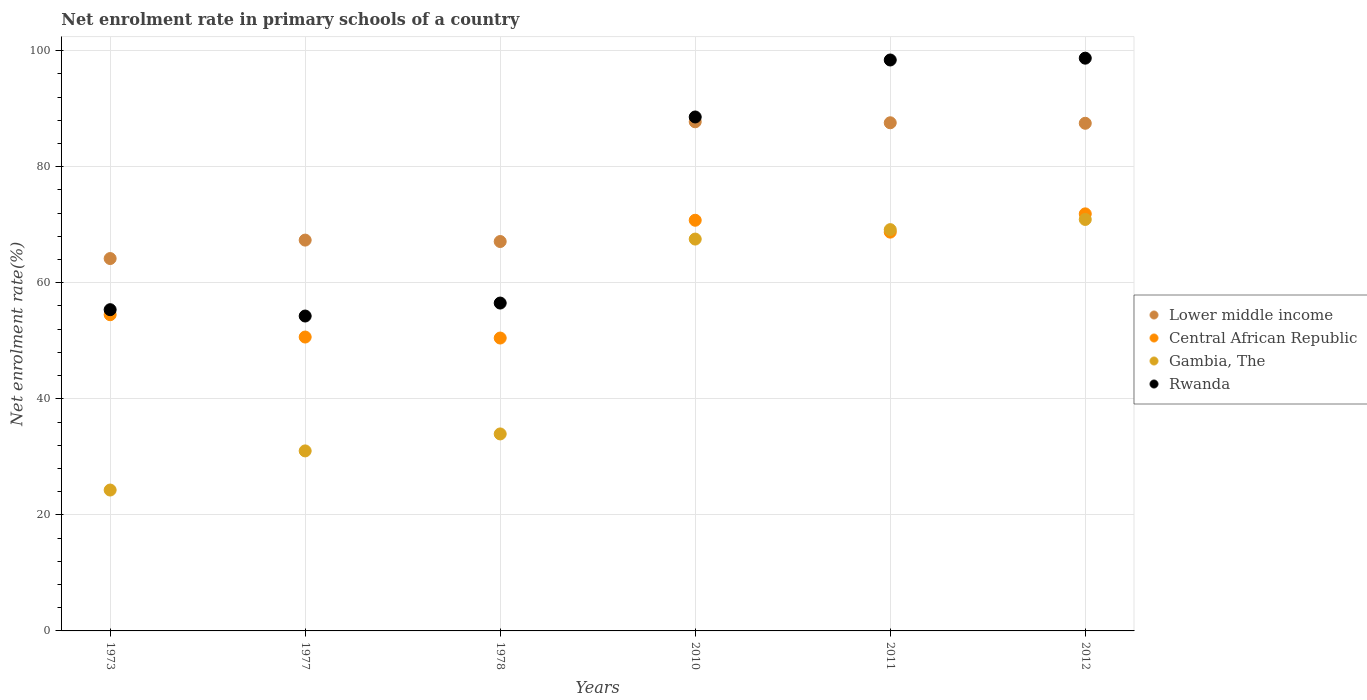Is the number of dotlines equal to the number of legend labels?
Your response must be concise. Yes. What is the net enrolment rate in primary schools in Lower middle income in 1977?
Provide a short and direct response. 67.35. Across all years, what is the maximum net enrolment rate in primary schools in Central African Republic?
Your answer should be very brief. 71.88. Across all years, what is the minimum net enrolment rate in primary schools in Central African Republic?
Give a very brief answer. 50.48. In which year was the net enrolment rate in primary schools in Gambia, The maximum?
Your response must be concise. 2012. What is the total net enrolment rate in primary schools in Rwanda in the graph?
Provide a short and direct response. 451.81. What is the difference between the net enrolment rate in primary schools in Gambia, The in 1978 and that in 2012?
Ensure brevity in your answer.  -36.96. What is the difference between the net enrolment rate in primary schools in Lower middle income in 1973 and the net enrolment rate in primary schools in Gambia, The in 2010?
Your answer should be very brief. -3.36. What is the average net enrolment rate in primary schools in Central African Republic per year?
Your answer should be compact. 61.17. In the year 2012, what is the difference between the net enrolment rate in primary schools in Rwanda and net enrolment rate in primary schools in Gambia, The?
Make the answer very short. 27.8. What is the ratio of the net enrolment rate in primary schools in Gambia, The in 2011 to that in 2012?
Give a very brief answer. 0.98. What is the difference between the highest and the second highest net enrolment rate in primary schools in Central African Republic?
Your answer should be very brief. 1.1. What is the difference between the highest and the lowest net enrolment rate in primary schools in Lower middle income?
Make the answer very short. 23.57. In how many years, is the net enrolment rate in primary schools in Rwanda greater than the average net enrolment rate in primary schools in Rwanda taken over all years?
Your response must be concise. 3. Is it the case that in every year, the sum of the net enrolment rate in primary schools in Rwanda and net enrolment rate in primary schools in Lower middle income  is greater than the sum of net enrolment rate in primary schools in Central African Republic and net enrolment rate in primary schools in Gambia, The?
Make the answer very short. Yes. Is it the case that in every year, the sum of the net enrolment rate in primary schools in Rwanda and net enrolment rate in primary schools in Central African Republic  is greater than the net enrolment rate in primary schools in Lower middle income?
Your answer should be compact. Yes. Does the net enrolment rate in primary schools in Lower middle income monotonically increase over the years?
Keep it short and to the point. No. Is the net enrolment rate in primary schools in Lower middle income strictly greater than the net enrolment rate in primary schools in Rwanda over the years?
Your answer should be compact. No. How many dotlines are there?
Your answer should be very brief. 4. How many years are there in the graph?
Your response must be concise. 6. Does the graph contain grids?
Offer a terse response. Yes. How many legend labels are there?
Offer a terse response. 4. How are the legend labels stacked?
Your response must be concise. Vertical. What is the title of the graph?
Provide a short and direct response. Net enrolment rate in primary schools of a country. Does "Norway" appear as one of the legend labels in the graph?
Give a very brief answer. No. What is the label or title of the X-axis?
Your response must be concise. Years. What is the label or title of the Y-axis?
Provide a succinct answer. Net enrolment rate(%). What is the Net enrolment rate(%) of Lower middle income in 1973?
Provide a succinct answer. 64.18. What is the Net enrolment rate(%) in Central African Republic in 1973?
Make the answer very short. 54.5. What is the Net enrolment rate(%) in Gambia, The in 1973?
Ensure brevity in your answer.  24.28. What is the Net enrolment rate(%) of Rwanda in 1973?
Give a very brief answer. 55.36. What is the Net enrolment rate(%) in Lower middle income in 1977?
Keep it short and to the point. 67.35. What is the Net enrolment rate(%) of Central African Republic in 1977?
Provide a short and direct response. 50.65. What is the Net enrolment rate(%) of Gambia, The in 1977?
Give a very brief answer. 31.02. What is the Net enrolment rate(%) in Rwanda in 1977?
Your answer should be very brief. 54.27. What is the Net enrolment rate(%) of Lower middle income in 1978?
Offer a terse response. 67.11. What is the Net enrolment rate(%) of Central African Republic in 1978?
Ensure brevity in your answer.  50.48. What is the Net enrolment rate(%) in Gambia, The in 1978?
Your response must be concise. 33.95. What is the Net enrolment rate(%) of Rwanda in 1978?
Your answer should be very brief. 56.5. What is the Net enrolment rate(%) in Lower middle income in 2010?
Ensure brevity in your answer.  87.74. What is the Net enrolment rate(%) in Central African Republic in 2010?
Keep it short and to the point. 70.77. What is the Net enrolment rate(%) of Gambia, The in 2010?
Provide a short and direct response. 67.53. What is the Net enrolment rate(%) in Rwanda in 2010?
Keep it short and to the point. 88.57. What is the Net enrolment rate(%) of Lower middle income in 2011?
Your answer should be very brief. 87.57. What is the Net enrolment rate(%) of Central African Republic in 2011?
Provide a short and direct response. 68.73. What is the Net enrolment rate(%) of Gambia, The in 2011?
Your answer should be very brief. 69.16. What is the Net enrolment rate(%) in Rwanda in 2011?
Provide a short and direct response. 98.39. What is the Net enrolment rate(%) of Lower middle income in 2012?
Give a very brief answer. 87.49. What is the Net enrolment rate(%) in Central African Republic in 2012?
Your answer should be compact. 71.88. What is the Net enrolment rate(%) of Gambia, The in 2012?
Give a very brief answer. 70.91. What is the Net enrolment rate(%) in Rwanda in 2012?
Provide a succinct answer. 98.71. Across all years, what is the maximum Net enrolment rate(%) of Lower middle income?
Offer a terse response. 87.74. Across all years, what is the maximum Net enrolment rate(%) of Central African Republic?
Your answer should be very brief. 71.88. Across all years, what is the maximum Net enrolment rate(%) of Gambia, The?
Your answer should be compact. 70.91. Across all years, what is the maximum Net enrolment rate(%) of Rwanda?
Offer a terse response. 98.71. Across all years, what is the minimum Net enrolment rate(%) in Lower middle income?
Your answer should be compact. 64.18. Across all years, what is the minimum Net enrolment rate(%) of Central African Republic?
Make the answer very short. 50.48. Across all years, what is the minimum Net enrolment rate(%) in Gambia, The?
Your response must be concise. 24.28. Across all years, what is the minimum Net enrolment rate(%) of Rwanda?
Ensure brevity in your answer.  54.27. What is the total Net enrolment rate(%) in Lower middle income in the graph?
Offer a terse response. 461.44. What is the total Net enrolment rate(%) of Central African Republic in the graph?
Ensure brevity in your answer.  367. What is the total Net enrolment rate(%) of Gambia, The in the graph?
Offer a very short reply. 296.86. What is the total Net enrolment rate(%) of Rwanda in the graph?
Your answer should be very brief. 451.81. What is the difference between the Net enrolment rate(%) in Lower middle income in 1973 and that in 1977?
Your answer should be very brief. -3.18. What is the difference between the Net enrolment rate(%) of Central African Republic in 1973 and that in 1977?
Give a very brief answer. 3.85. What is the difference between the Net enrolment rate(%) in Gambia, The in 1973 and that in 1977?
Your answer should be very brief. -6.74. What is the difference between the Net enrolment rate(%) of Rwanda in 1973 and that in 1977?
Your answer should be very brief. 1.09. What is the difference between the Net enrolment rate(%) in Lower middle income in 1973 and that in 1978?
Your answer should be compact. -2.93. What is the difference between the Net enrolment rate(%) of Central African Republic in 1973 and that in 1978?
Provide a succinct answer. 4.02. What is the difference between the Net enrolment rate(%) in Gambia, The in 1973 and that in 1978?
Your response must be concise. -9.67. What is the difference between the Net enrolment rate(%) in Rwanda in 1973 and that in 1978?
Provide a succinct answer. -1.14. What is the difference between the Net enrolment rate(%) in Lower middle income in 1973 and that in 2010?
Offer a very short reply. -23.57. What is the difference between the Net enrolment rate(%) of Central African Republic in 1973 and that in 2010?
Offer a very short reply. -16.28. What is the difference between the Net enrolment rate(%) of Gambia, The in 1973 and that in 2010?
Your response must be concise. -43.25. What is the difference between the Net enrolment rate(%) in Rwanda in 1973 and that in 2010?
Give a very brief answer. -33.21. What is the difference between the Net enrolment rate(%) of Lower middle income in 1973 and that in 2011?
Provide a short and direct response. -23.4. What is the difference between the Net enrolment rate(%) in Central African Republic in 1973 and that in 2011?
Give a very brief answer. -14.23. What is the difference between the Net enrolment rate(%) of Gambia, The in 1973 and that in 2011?
Your answer should be compact. -44.88. What is the difference between the Net enrolment rate(%) of Rwanda in 1973 and that in 2011?
Give a very brief answer. -43.03. What is the difference between the Net enrolment rate(%) in Lower middle income in 1973 and that in 2012?
Ensure brevity in your answer.  -23.31. What is the difference between the Net enrolment rate(%) in Central African Republic in 1973 and that in 2012?
Your response must be concise. -17.38. What is the difference between the Net enrolment rate(%) in Gambia, The in 1973 and that in 2012?
Offer a very short reply. -46.63. What is the difference between the Net enrolment rate(%) in Rwanda in 1973 and that in 2012?
Provide a short and direct response. -43.35. What is the difference between the Net enrolment rate(%) in Lower middle income in 1977 and that in 1978?
Ensure brevity in your answer.  0.24. What is the difference between the Net enrolment rate(%) in Central African Republic in 1977 and that in 1978?
Your response must be concise. 0.17. What is the difference between the Net enrolment rate(%) of Gambia, The in 1977 and that in 1978?
Provide a short and direct response. -2.92. What is the difference between the Net enrolment rate(%) in Rwanda in 1977 and that in 1978?
Offer a very short reply. -2.24. What is the difference between the Net enrolment rate(%) of Lower middle income in 1977 and that in 2010?
Keep it short and to the point. -20.39. What is the difference between the Net enrolment rate(%) of Central African Republic in 1977 and that in 2010?
Offer a terse response. -20.13. What is the difference between the Net enrolment rate(%) of Gambia, The in 1977 and that in 2010?
Keep it short and to the point. -36.51. What is the difference between the Net enrolment rate(%) of Rwanda in 1977 and that in 2010?
Make the answer very short. -34.3. What is the difference between the Net enrolment rate(%) of Lower middle income in 1977 and that in 2011?
Provide a succinct answer. -20.22. What is the difference between the Net enrolment rate(%) of Central African Republic in 1977 and that in 2011?
Give a very brief answer. -18.08. What is the difference between the Net enrolment rate(%) in Gambia, The in 1977 and that in 2011?
Offer a very short reply. -38.13. What is the difference between the Net enrolment rate(%) of Rwanda in 1977 and that in 2011?
Your response must be concise. -44.13. What is the difference between the Net enrolment rate(%) in Lower middle income in 1977 and that in 2012?
Make the answer very short. -20.13. What is the difference between the Net enrolment rate(%) in Central African Republic in 1977 and that in 2012?
Ensure brevity in your answer.  -21.23. What is the difference between the Net enrolment rate(%) of Gambia, The in 1977 and that in 2012?
Provide a succinct answer. -39.89. What is the difference between the Net enrolment rate(%) of Rwanda in 1977 and that in 2012?
Your response must be concise. -44.44. What is the difference between the Net enrolment rate(%) of Lower middle income in 1978 and that in 2010?
Keep it short and to the point. -20.63. What is the difference between the Net enrolment rate(%) in Central African Republic in 1978 and that in 2010?
Make the answer very short. -20.3. What is the difference between the Net enrolment rate(%) of Gambia, The in 1978 and that in 2010?
Make the answer very short. -33.58. What is the difference between the Net enrolment rate(%) of Rwanda in 1978 and that in 2010?
Offer a very short reply. -32.07. What is the difference between the Net enrolment rate(%) in Lower middle income in 1978 and that in 2011?
Ensure brevity in your answer.  -20.46. What is the difference between the Net enrolment rate(%) of Central African Republic in 1978 and that in 2011?
Provide a succinct answer. -18.25. What is the difference between the Net enrolment rate(%) in Gambia, The in 1978 and that in 2011?
Give a very brief answer. -35.21. What is the difference between the Net enrolment rate(%) in Rwanda in 1978 and that in 2011?
Your answer should be compact. -41.89. What is the difference between the Net enrolment rate(%) of Lower middle income in 1978 and that in 2012?
Offer a terse response. -20.38. What is the difference between the Net enrolment rate(%) of Central African Republic in 1978 and that in 2012?
Make the answer very short. -21.4. What is the difference between the Net enrolment rate(%) of Gambia, The in 1978 and that in 2012?
Keep it short and to the point. -36.96. What is the difference between the Net enrolment rate(%) in Rwanda in 1978 and that in 2012?
Ensure brevity in your answer.  -42.2. What is the difference between the Net enrolment rate(%) in Lower middle income in 2010 and that in 2011?
Give a very brief answer. 0.17. What is the difference between the Net enrolment rate(%) in Central African Republic in 2010 and that in 2011?
Your answer should be very brief. 2.05. What is the difference between the Net enrolment rate(%) in Gambia, The in 2010 and that in 2011?
Offer a very short reply. -1.63. What is the difference between the Net enrolment rate(%) of Rwanda in 2010 and that in 2011?
Offer a terse response. -9.82. What is the difference between the Net enrolment rate(%) in Lower middle income in 2010 and that in 2012?
Offer a very short reply. 0.25. What is the difference between the Net enrolment rate(%) of Central African Republic in 2010 and that in 2012?
Give a very brief answer. -1.1. What is the difference between the Net enrolment rate(%) in Gambia, The in 2010 and that in 2012?
Give a very brief answer. -3.38. What is the difference between the Net enrolment rate(%) in Rwanda in 2010 and that in 2012?
Your response must be concise. -10.14. What is the difference between the Net enrolment rate(%) of Lower middle income in 2011 and that in 2012?
Your response must be concise. 0.09. What is the difference between the Net enrolment rate(%) of Central African Republic in 2011 and that in 2012?
Offer a terse response. -3.15. What is the difference between the Net enrolment rate(%) in Gambia, The in 2011 and that in 2012?
Provide a succinct answer. -1.75. What is the difference between the Net enrolment rate(%) in Rwanda in 2011 and that in 2012?
Ensure brevity in your answer.  -0.31. What is the difference between the Net enrolment rate(%) of Lower middle income in 1973 and the Net enrolment rate(%) of Central African Republic in 1977?
Make the answer very short. 13.53. What is the difference between the Net enrolment rate(%) in Lower middle income in 1973 and the Net enrolment rate(%) in Gambia, The in 1977?
Provide a succinct answer. 33.15. What is the difference between the Net enrolment rate(%) of Lower middle income in 1973 and the Net enrolment rate(%) of Rwanda in 1977?
Your response must be concise. 9.91. What is the difference between the Net enrolment rate(%) of Central African Republic in 1973 and the Net enrolment rate(%) of Gambia, The in 1977?
Provide a succinct answer. 23.47. What is the difference between the Net enrolment rate(%) in Central African Republic in 1973 and the Net enrolment rate(%) in Rwanda in 1977?
Provide a succinct answer. 0.23. What is the difference between the Net enrolment rate(%) in Gambia, The in 1973 and the Net enrolment rate(%) in Rwanda in 1977?
Your answer should be compact. -29.99. What is the difference between the Net enrolment rate(%) of Lower middle income in 1973 and the Net enrolment rate(%) of Central African Republic in 1978?
Ensure brevity in your answer.  13.7. What is the difference between the Net enrolment rate(%) of Lower middle income in 1973 and the Net enrolment rate(%) of Gambia, The in 1978?
Offer a terse response. 30.23. What is the difference between the Net enrolment rate(%) of Lower middle income in 1973 and the Net enrolment rate(%) of Rwanda in 1978?
Give a very brief answer. 7.67. What is the difference between the Net enrolment rate(%) of Central African Republic in 1973 and the Net enrolment rate(%) of Gambia, The in 1978?
Ensure brevity in your answer.  20.55. What is the difference between the Net enrolment rate(%) in Central African Republic in 1973 and the Net enrolment rate(%) in Rwanda in 1978?
Provide a short and direct response. -2.01. What is the difference between the Net enrolment rate(%) of Gambia, The in 1973 and the Net enrolment rate(%) of Rwanda in 1978?
Your answer should be very brief. -32.23. What is the difference between the Net enrolment rate(%) in Lower middle income in 1973 and the Net enrolment rate(%) in Central African Republic in 2010?
Your answer should be very brief. -6.6. What is the difference between the Net enrolment rate(%) of Lower middle income in 1973 and the Net enrolment rate(%) of Gambia, The in 2010?
Provide a succinct answer. -3.36. What is the difference between the Net enrolment rate(%) of Lower middle income in 1973 and the Net enrolment rate(%) of Rwanda in 2010?
Your response must be concise. -24.4. What is the difference between the Net enrolment rate(%) in Central African Republic in 1973 and the Net enrolment rate(%) in Gambia, The in 2010?
Give a very brief answer. -13.04. What is the difference between the Net enrolment rate(%) in Central African Republic in 1973 and the Net enrolment rate(%) in Rwanda in 2010?
Make the answer very short. -34.08. What is the difference between the Net enrolment rate(%) of Gambia, The in 1973 and the Net enrolment rate(%) of Rwanda in 2010?
Your answer should be very brief. -64.29. What is the difference between the Net enrolment rate(%) in Lower middle income in 1973 and the Net enrolment rate(%) in Central African Republic in 2011?
Make the answer very short. -4.55. What is the difference between the Net enrolment rate(%) of Lower middle income in 1973 and the Net enrolment rate(%) of Gambia, The in 2011?
Keep it short and to the point. -4.98. What is the difference between the Net enrolment rate(%) in Lower middle income in 1973 and the Net enrolment rate(%) in Rwanda in 2011?
Give a very brief answer. -34.22. What is the difference between the Net enrolment rate(%) of Central African Republic in 1973 and the Net enrolment rate(%) of Gambia, The in 2011?
Offer a very short reply. -14.66. What is the difference between the Net enrolment rate(%) in Central African Republic in 1973 and the Net enrolment rate(%) in Rwanda in 2011?
Ensure brevity in your answer.  -43.9. What is the difference between the Net enrolment rate(%) in Gambia, The in 1973 and the Net enrolment rate(%) in Rwanda in 2011?
Make the answer very short. -74.12. What is the difference between the Net enrolment rate(%) of Lower middle income in 1973 and the Net enrolment rate(%) of Central African Republic in 2012?
Your response must be concise. -7.7. What is the difference between the Net enrolment rate(%) in Lower middle income in 1973 and the Net enrolment rate(%) in Gambia, The in 2012?
Offer a very short reply. -6.74. What is the difference between the Net enrolment rate(%) of Lower middle income in 1973 and the Net enrolment rate(%) of Rwanda in 2012?
Give a very brief answer. -34.53. What is the difference between the Net enrolment rate(%) in Central African Republic in 1973 and the Net enrolment rate(%) in Gambia, The in 2012?
Offer a very short reply. -16.42. What is the difference between the Net enrolment rate(%) of Central African Republic in 1973 and the Net enrolment rate(%) of Rwanda in 2012?
Keep it short and to the point. -44.21. What is the difference between the Net enrolment rate(%) in Gambia, The in 1973 and the Net enrolment rate(%) in Rwanda in 2012?
Your response must be concise. -74.43. What is the difference between the Net enrolment rate(%) of Lower middle income in 1977 and the Net enrolment rate(%) of Central African Republic in 1978?
Provide a succinct answer. 16.88. What is the difference between the Net enrolment rate(%) of Lower middle income in 1977 and the Net enrolment rate(%) of Gambia, The in 1978?
Give a very brief answer. 33.41. What is the difference between the Net enrolment rate(%) of Lower middle income in 1977 and the Net enrolment rate(%) of Rwanda in 1978?
Give a very brief answer. 10.85. What is the difference between the Net enrolment rate(%) in Central African Republic in 1977 and the Net enrolment rate(%) in Gambia, The in 1978?
Offer a very short reply. 16.7. What is the difference between the Net enrolment rate(%) in Central African Republic in 1977 and the Net enrolment rate(%) in Rwanda in 1978?
Offer a very short reply. -5.86. What is the difference between the Net enrolment rate(%) in Gambia, The in 1977 and the Net enrolment rate(%) in Rwanda in 1978?
Your response must be concise. -25.48. What is the difference between the Net enrolment rate(%) in Lower middle income in 1977 and the Net enrolment rate(%) in Central African Republic in 2010?
Ensure brevity in your answer.  -3.42. What is the difference between the Net enrolment rate(%) of Lower middle income in 1977 and the Net enrolment rate(%) of Gambia, The in 2010?
Offer a terse response. -0.18. What is the difference between the Net enrolment rate(%) of Lower middle income in 1977 and the Net enrolment rate(%) of Rwanda in 2010?
Ensure brevity in your answer.  -21.22. What is the difference between the Net enrolment rate(%) of Central African Republic in 1977 and the Net enrolment rate(%) of Gambia, The in 2010?
Make the answer very short. -16.88. What is the difference between the Net enrolment rate(%) of Central African Republic in 1977 and the Net enrolment rate(%) of Rwanda in 2010?
Offer a very short reply. -37.93. What is the difference between the Net enrolment rate(%) of Gambia, The in 1977 and the Net enrolment rate(%) of Rwanda in 2010?
Give a very brief answer. -57.55. What is the difference between the Net enrolment rate(%) in Lower middle income in 1977 and the Net enrolment rate(%) in Central African Republic in 2011?
Provide a short and direct response. -1.37. What is the difference between the Net enrolment rate(%) of Lower middle income in 1977 and the Net enrolment rate(%) of Gambia, The in 2011?
Make the answer very short. -1.8. What is the difference between the Net enrolment rate(%) in Lower middle income in 1977 and the Net enrolment rate(%) in Rwanda in 2011?
Your response must be concise. -31.04. What is the difference between the Net enrolment rate(%) of Central African Republic in 1977 and the Net enrolment rate(%) of Gambia, The in 2011?
Provide a short and direct response. -18.51. What is the difference between the Net enrolment rate(%) in Central African Republic in 1977 and the Net enrolment rate(%) in Rwanda in 2011?
Provide a succinct answer. -47.75. What is the difference between the Net enrolment rate(%) in Gambia, The in 1977 and the Net enrolment rate(%) in Rwanda in 2011?
Provide a succinct answer. -67.37. What is the difference between the Net enrolment rate(%) in Lower middle income in 1977 and the Net enrolment rate(%) in Central African Republic in 2012?
Offer a very short reply. -4.52. What is the difference between the Net enrolment rate(%) of Lower middle income in 1977 and the Net enrolment rate(%) of Gambia, The in 2012?
Provide a succinct answer. -3.56. What is the difference between the Net enrolment rate(%) of Lower middle income in 1977 and the Net enrolment rate(%) of Rwanda in 2012?
Give a very brief answer. -31.35. What is the difference between the Net enrolment rate(%) in Central African Republic in 1977 and the Net enrolment rate(%) in Gambia, The in 2012?
Your answer should be compact. -20.27. What is the difference between the Net enrolment rate(%) in Central African Republic in 1977 and the Net enrolment rate(%) in Rwanda in 2012?
Offer a very short reply. -48.06. What is the difference between the Net enrolment rate(%) in Gambia, The in 1977 and the Net enrolment rate(%) in Rwanda in 2012?
Provide a succinct answer. -67.68. What is the difference between the Net enrolment rate(%) in Lower middle income in 1978 and the Net enrolment rate(%) in Central African Republic in 2010?
Keep it short and to the point. -3.66. What is the difference between the Net enrolment rate(%) of Lower middle income in 1978 and the Net enrolment rate(%) of Gambia, The in 2010?
Provide a succinct answer. -0.42. What is the difference between the Net enrolment rate(%) of Lower middle income in 1978 and the Net enrolment rate(%) of Rwanda in 2010?
Provide a succinct answer. -21.46. What is the difference between the Net enrolment rate(%) in Central African Republic in 1978 and the Net enrolment rate(%) in Gambia, The in 2010?
Your response must be concise. -17.06. What is the difference between the Net enrolment rate(%) in Central African Republic in 1978 and the Net enrolment rate(%) in Rwanda in 2010?
Your answer should be very brief. -38.1. What is the difference between the Net enrolment rate(%) in Gambia, The in 1978 and the Net enrolment rate(%) in Rwanda in 2010?
Your answer should be very brief. -54.62. What is the difference between the Net enrolment rate(%) of Lower middle income in 1978 and the Net enrolment rate(%) of Central African Republic in 2011?
Ensure brevity in your answer.  -1.62. What is the difference between the Net enrolment rate(%) of Lower middle income in 1978 and the Net enrolment rate(%) of Gambia, The in 2011?
Keep it short and to the point. -2.05. What is the difference between the Net enrolment rate(%) of Lower middle income in 1978 and the Net enrolment rate(%) of Rwanda in 2011?
Provide a succinct answer. -31.28. What is the difference between the Net enrolment rate(%) in Central African Republic in 1978 and the Net enrolment rate(%) in Gambia, The in 2011?
Ensure brevity in your answer.  -18.68. What is the difference between the Net enrolment rate(%) in Central African Republic in 1978 and the Net enrolment rate(%) in Rwanda in 2011?
Offer a terse response. -47.92. What is the difference between the Net enrolment rate(%) of Gambia, The in 1978 and the Net enrolment rate(%) of Rwanda in 2011?
Offer a very short reply. -64.45. What is the difference between the Net enrolment rate(%) in Lower middle income in 1978 and the Net enrolment rate(%) in Central African Republic in 2012?
Your answer should be compact. -4.77. What is the difference between the Net enrolment rate(%) in Lower middle income in 1978 and the Net enrolment rate(%) in Gambia, The in 2012?
Provide a succinct answer. -3.8. What is the difference between the Net enrolment rate(%) of Lower middle income in 1978 and the Net enrolment rate(%) of Rwanda in 2012?
Your answer should be very brief. -31.6. What is the difference between the Net enrolment rate(%) in Central African Republic in 1978 and the Net enrolment rate(%) in Gambia, The in 2012?
Give a very brief answer. -20.44. What is the difference between the Net enrolment rate(%) in Central African Republic in 1978 and the Net enrolment rate(%) in Rwanda in 2012?
Your answer should be compact. -48.23. What is the difference between the Net enrolment rate(%) in Gambia, The in 1978 and the Net enrolment rate(%) in Rwanda in 2012?
Offer a very short reply. -64.76. What is the difference between the Net enrolment rate(%) of Lower middle income in 2010 and the Net enrolment rate(%) of Central African Republic in 2011?
Provide a succinct answer. 19.01. What is the difference between the Net enrolment rate(%) of Lower middle income in 2010 and the Net enrolment rate(%) of Gambia, The in 2011?
Your answer should be very brief. 18.58. What is the difference between the Net enrolment rate(%) of Lower middle income in 2010 and the Net enrolment rate(%) of Rwanda in 2011?
Provide a succinct answer. -10.65. What is the difference between the Net enrolment rate(%) of Central African Republic in 2010 and the Net enrolment rate(%) of Gambia, The in 2011?
Provide a short and direct response. 1.62. What is the difference between the Net enrolment rate(%) of Central African Republic in 2010 and the Net enrolment rate(%) of Rwanda in 2011?
Offer a terse response. -27.62. What is the difference between the Net enrolment rate(%) in Gambia, The in 2010 and the Net enrolment rate(%) in Rwanda in 2011?
Offer a very short reply. -30.86. What is the difference between the Net enrolment rate(%) of Lower middle income in 2010 and the Net enrolment rate(%) of Central African Republic in 2012?
Offer a terse response. 15.87. What is the difference between the Net enrolment rate(%) of Lower middle income in 2010 and the Net enrolment rate(%) of Gambia, The in 2012?
Provide a succinct answer. 16.83. What is the difference between the Net enrolment rate(%) in Lower middle income in 2010 and the Net enrolment rate(%) in Rwanda in 2012?
Ensure brevity in your answer.  -10.97. What is the difference between the Net enrolment rate(%) in Central African Republic in 2010 and the Net enrolment rate(%) in Gambia, The in 2012?
Provide a short and direct response. -0.14. What is the difference between the Net enrolment rate(%) in Central African Republic in 2010 and the Net enrolment rate(%) in Rwanda in 2012?
Your response must be concise. -27.93. What is the difference between the Net enrolment rate(%) in Gambia, The in 2010 and the Net enrolment rate(%) in Rwanda in 2012?
Your answer should be compact. -31.18. What is the difference between the Net enrolment rate(%) in Lower middle income in 2011 and the Net enrolment rate(%) in Central African Republic in 2012?
Give a very brief answer. 15.7. What is the difference between the Net enrolment rate(%) of Lower middle income in 2011 and the Net enrolment rate(%) of Gambia, The in 2012?
Provide a succinct answer. 16.66. What is the difference between the Net enrolment rate(%) of Lower middle income in 2011 and the Net enrolment rate(%) of Rwanda in 2012?
Your answer should be very brief. -11.13. What is the difference between the Net enrolment rate(%) in Central African Republic in 2011 and the Net enrolment rate(%) in Gambia, The in 2012?
Provide a short and direct response. -2.19. What is the difference between the Net enrolment rate(%) in Central African Republic in 2011 and the Net enrolment rate(%) in Rwanda in 2012?
Provide a short and direct response. -29.98. What is the difference between the Net enrolment rate(%) of Gambia, The in 2011 and the Net enrolment rate(%) of Rwanda in 2012?
Your response must be concise. -29.55. What is the average Net enrolment rate(%) of Lower middle income per year?
Your answer should be compact. 76.91. What is the average Net enrolment rate(%) in Central African Republic per year?
Your answer should be compact. 61.17. What is the average Net enrolment rate(%) of Gambia, The per year?
Give a very brief answer. 49.48. What is the average Net enrolment rate(%) in Rwanda per year?
Give a very brief answer. 75.3. In the year 1973, what is the difference between the Net enrolment rate(%) of Lower middle income and Net enrolment rate(%) of Central African Republic?
Offer a terse response. 9.68. In the year 1973, what is the difference between the Net enrolment rate(%) of Lower middle income and Net enrolment rate(%) of Gambia, The?
Your response must be concise. 39.9. In the year 1973, what is the difference between the Net enrolment rate(%) in Lower middle income and Net enrolment rate(%) in Rwanda?
Provide a succinct answer. 8.81. In the year 1973, what is the difference between the Net enrolment rate(%) of Central African Republic and Net enrolment rate(%) of Gambia, The?
Provide a short and direct response. 30.22. In the year 1973, what is the difference between the Net enrolment rate(%) of Central African Republic and Net enrolment rate(%) of Rwanda?
Give a very brief answer. -0.87. In the year 1973, what is the difference between the Net enrolment rate(%) of Gambia, The and Net enrolment rate(%) of Rwanda?
Your response must be concise. -31.08. In the year 1977, what is the difference between the Net enrolment rate(%) in Lower middle income and Net enrolment rate(%) in Central African Republic?
Give a very brief answer. 16.71. In the year 1977, what is the difference between the Net enrolment rate(%) of Lower middle income and Net enrolment rate(%) of Gambia, The?
Provide a short and direct response. 36.33. In the year 1977, what is the difference between the Net enrolment rate(%) of Lower middle income and Net enrolment rate(%) of Rwanda?
Provide a short and direct response. 13.08. In the year 1977, what is the difference between the Net enrolment rate(%) of Central African Republic and Net enrolment rate(%) of Gambia, The?
Offer a terse response. 19.62. In the year 1977, what is the difference between the Net enrolment rate(%) in Central African Republic and Net enrolment rate(%) in Rwanda?
Your response must be concise. -3.62. In the year 1977, what is the difference between the Net enrolment rate(%) in Gambia, The and Net enrolment rate(%) in Rwanda?
Your answer should be compact. -23.25. In the year 1978, what is the difference between the Net enrolment rate(%) of Lower middle income and Net enrolment rate(%) of Central African Republic?
Provide a succinct answer. 16.63. In the year 1978, what is the difference between the Net enrolment rate(%) in Lower middle income and Net enrolment rate(%) in Gambia, The?
Keep it short and to the point. 33.16. In the year 1978, what is the difference between the Net enrolment rate(%) of Lower middle income and Net enrolment rate(%) of Rwanda?
Ensure brevity in your answer.  10.61. In the year 1978, what is the difference between the Net enrolment rate(%) in Central African Republic and Net enrolment rate(%) in Gambia, The?
Provide a short and direct response. 16.53. In the year 1978, what is the difference between the Net enrolment rate(%) in Central African Republic and Net enrolment rate(%) in Rwanda?
Make the answer very short. -6.03. In the year 1978, what is the difference between the Net enrolment rate(%) in Gambia, The and Net enrolment rate(%) in Rwanda?
Provide a short and direct response. -22.56. In the year 2010, what is the difference between the Net enrolment rate(%) in Lower middle income and Net enrolment rate(%) in Central African Republic?
Ensure brevity in your answer.  16.97. In the year 2010, what is the difference between the Net enrolment rate(%) in Lower middle income and Net enrolment rate(%) in Gambia, The?
Give a very brief answer. 20.21. In the year 2010, what is the difference between the Net enrolment rate(%) of Lower middle income and Net enrolment rate(%) of Rwanda?
Provide a succinct answer. -0.83. In the year 2010, what is the difference between the Net enrolment rate(%) in Central African Republic and Net enrolment rate(%) in Gambia, The?
Provide a short and direct response. 3.24. In the year 2010, what is the difference between the Net enrolment rate(%) of Central African Republic and Net enrolment rate(%) of Rwanda?
Your answer should be compact. -17.8. In the year 2010, what is the difference between the Net enrolment rate(%) in Gambia, The and Net enrolment rate(%) in Rwanda?
Make the answer very short. -21.04. In the year 2011, what is the difference between the Net enrolment rate(%) in Lower middle income and Net enrolment rate(%) in Central African Republic?
Your answer should be very brief. 18.85. In the year 2011, what is the difference between the Net enrolment rate(%) of Lower middle income and Net enrolment rate(%) of Gambia, The?
Offer a terse response. 18.42. In the year 2011, what is the difference between the Net enrolment rate(%) in Lower middle income and Net enrolment rate(%) in Rwanda?
Offer a terse response. -10.82. In the year 2011, what is the difference between the Net enrolment rate(%) of Central African Republic and Net enrolment rate(%) of Gambia, The?
Offer a terse response. -0.43. In the year 2011, what is the difference between the Net enrolment rate(%) of Central African Republic and Net enrolment rate(%) of Rwanda?
Your response must be concise. -29.67. In the year 2011, what is the difference between the Net enrolment rate(%) in Gambia, The and Net enrolment rate(%) in Rwanda?
Your answer should be compact. -29.24. In the year 2012, what is the difference between the Net enrolment rate(%) in Lower middle income and Net enrolment rate(%) in Central African Republic?
Offer a very short reply. 15.61. In the year 2012, what is the difference between the Net enrolment rate(%) of Lower middle income and Net enrolment rate(%) of Gambia, The?
Your response must be concise. 16.57. In the year 2012, what is the difference between the Net enrolment rate(%) of Lower middle income and Net enrolment rate(%) of Rwanda?
Provide a succinct answer. -11.22. In the year 2012, what is the difference between the Net enrolment rate(%) of Central African Republic and Net enrolment rate(%) of Gambia, The?
Give a very brief answer. 0.96. In the year 2012, what is the difference between the Net enrolment rate(%) of Central African Republic and Net enrolment rate(%) of Rwanda?
Make the answer very short. -26.83. In the year 2012, what is the difference between the Net enrolment rate(%) of Gambia, The and Net enrolment rate(%) of Rwanda?
Your answer should be compact. -27.8. What is the ratio of the Net enrolment rate(%) in Lower middle income in 1973 to that in 1977?
Your response must be concise. 0.95. What is the ratio of the Net enrolment rate(%) of Central African Republic in 1973 to that in 1977?
Your answer should be compact. 1.08. What is the ratio of the Net enrolment rate(%) of Gambia, The in 1973 to that in 1977?
Offer a terse response. 0.78. What is the ratio of the Net enrolment rate(%) in Rwanda in 1973 to that in 1977?
Offer a very short reply. 1.02. What is the ratio of the Net enrolment rate(%) in Lower middle income in 1973 to that in 1978?
Keep it short and to the point. 0.96. What is the ratio of the Net enrolment rate(%) of Central African Republic in 1973 to that in 1978?
Ensure brevity in your answer.  1.08. What is the ratio of the Net enrolment rate(%) of Gambia, The in 1973 to that in 1978?
Provide a short and direct response. 0.72. What is the ratio of the Net enrolment rate(%) in Rwanda in 1973 to that in 1978?
Give a very brief answer. 0.98. What is the ratio of the Net enrolment rate(%) in Lower middle income in 1973 to that in 2010?
Keep it short and to the point. 0.73. What is the ratio of the Net enrolment rate(%) of Central African Republic in 1973 to that in 2010?
Ensure brevity in your answer.  0.77. What is the ratio of the Net enrolment rate(%) of Gambia, The in 1973 to that in 2010?
Ensure brevity in your answer.  0.36. What is the ratio of the Net enrolment rate(%) in Lower middle income in 1973 to that in 2011?
Give a very brief answer. 0.73. What is the ratio of the Net enrolment rate(%) in Central African Republic in 1973 to that in 2011?
Provide a short and direct response. 0.79. What is the ratio of the Net enrolment rate(%) of Gambia, The in 1973 to that in 2011?
Offer a very short reply. 0.35. What is the ratio of the Net enrolment rate(%) of Rwanda in 1973 to that in 2011?
Ensure brevity in your answer.  0.56. What is the ratio of the Net enrolment rate(%) of Lower middle income in 1973 to that in 2012?
Keep it short and to the point. 0.73. What is the ratio of the Net enrolment rate(%) in Central African Republic in 1973 to that in 2012?
Provide a succinct answer. 0.76. What is the ratio of the Net enrolment rate(%) of Gambia, The in 1973 to that in 2012?
Your answer should be compact. 0.34. What is the ratio of the Net enrolment rate(%) in Rwanda in 1973 to that in 2012?
Provide a short and direct response. 0.56. What is the ratio of the Net enrolment rate(%) of Lower middle income in 1977 to that in 1978?
Make the answer very short. 1. What is the ratio of the Net enrolment rate(%) of Central African Republic in 1977 to that in 1978?
Provide a succinct answer. 1. What is the ratio of the Net enrolment rate(%) of Gambia, The in 1977 to that in 1978?
Ensure brevity in your answer.  0.91. What is the ratio of the Net enrolment rate(%) of Rwanda in 1977 to that in 1978?
Keep it short and to the point. 0.96. What is the ratio of the Net enrolment rate(%) of Lower middle income in 1977 to that in 2010?
Give a very brief answer. 0.77. What is the ratio of the Net enrolment rate(%) of Central African Republic in 1977 to that in 2010?
Offer a very short reply. 0.72. What is the ratio of the Net enrolment rate(%) of Gambia, The in 1977 to that in 2010?
Keep it short and to the point. 0.46. What is the ratio of the Net enrolment rate(%) in Rwanda in 1977 to that in 2010?
Offer a very short reply. 0.61. What is the ratio of the Net enrolment rate(%) of Lower middle income in 1977 to that in 2011?
Your response must be concise. 0.77. What is the ratio of the Net enrolment rate(%) in Central African Republic in 1977 to that in 2011?
Offer a terse response. 0.74. What is the ratio of the Net enrolment rate(%) in Gambia, The in 1977 to that in 2011?
Keep it short and to the point. 0.45. What is the ratio of the Net enrolment rate(%) in Rwanda in 1977 to that in 2011?
Your answer should be compact. 0.55. What is the ratio of the Net enrolment rate(%) in Lower middle income in 1977 to that in 2012?
Ensure brevity in your answer.  0.77. What is the ratio of the Net enrolment rate(%) of Central African Republic in 1977 to that in 2012?
Offer a very short reply. 0.7. What is the ratio of the Net enrolment rate(%) of Gambia, The in 1977 to that in 2012?
Make the answer very short. 0.44. What is the ratio of the Net enrolment rate(%) of Rwanda in 1977 to that in 2012?
Provide a succinct answer. 0.55. What is the ratio of the Net enrolment rate(%) of Lower middle income in 1978 to that in 2010?
Give a very brief answer. 0.76. What is the ratio of the Net enrolment rate(%) of Central African Republic in 1978 to that in 2010?
Give a very brief answer. 0.71. What is the ratio of the Net enrolment rate(%) in Gambia, The in 1978 to that in 2010?
Ensure brevity in your answer.  0.5. What is the ratio of the Net enrolment rate(%) in Rwanda in 1978 to that in 2010?
Your response must be concise. 0.64. What is the ratio of the Net enrolment rate(%) in Lower middle income in 1978 to that in 2011?
Ensure brevity in your answer.  0.77. What is the ratio of the Net enrolment rate(%) of Central African Republic in 1978 to that in 2011?
Make the answer very short. 0.73. What is the ratio of the Net enrolment rate(%) of Gambia, The in 1978 to that in 2011?
Offer a very short reply. 0.49. What is the ratio of the Net enrolment rate(%) in Rwanda in 1978 to that in 2011?
Provide a succinct answer. 0.57. What is the ratio of the Net enrolment rate(%) in Lower middle income in 1978 to that in 2012?
Your answer should be very brief. 0.77. What is the ratio of the Net enrolment rate(%) of Central African Republic in 1978 to that in 2012?
Offer a terse response. 0.7. What is the ratio of the Net enrolment rate(%) in Gambia, The in 1978 to that in 2012?
Keep it short and to the point. 0.48. What is the ratio of the Net enrolment rate(%) of Rwanda in 1978 to that in 2012?
Your answer should be compact. 0.57. What is the ratio of the Net enrolment rate(%) in Central African Republic in 2010 to that in 2011?
Offer a terse response. 1.03. What is the ratio of the Net enrolment rate(%) of Gambia, The in 2010 to that in 2011?
Provide a succinct answer. 0.98. What is the ratio of the Net enrolment rate(%) in Rwanda in 2010 to that in 2011?
Offer a terse response. 0.9. What is the ratio of the Net enrolment rate(%) in Lower middle income in 2010 to that in 2012?
Offer a terse response. 1. What is the ratio of the Net enrolment rate(%) of Central African Republic in 2010 to that in 2012?
Offer a very short reply. 0.98. What is the ratio of the Net enrolment rate(%) in Gambia, The in 2010 to that in 2012?
Offer a terse response. 0.95. What is the ratio of the Net enrolment rate(%) in Rwanda in 2010 to that in 2012?
Keep it short and to the point. 0.9. What is the ratio of the Net enrolment rate(%) of Central African Republic in 2011 to that in 2012?
Your answer should be compact. 0.96. What is the ratio of the Net enrolment rate(%) of Gambia, The in 2011 to that in 2012?
Your response must be concise. 0.98. What is the difference between the highest and the second highest Net enrolment rate(%) in Lower middle income?
Your response must be concise. 0.17. What is the difference between the highest and the second highest Net enrolment rate(%) of Central African Republic?
Provide a succinct answer. 1.1. What is the difference between the highest and the second highest Net enrolment rate(%) of Gambia, The?
Keep it short and to the point. 1.75. What is the difference between the highest and the second highest Net enrolment rate(%) in Rwanda?
Ensure brevity in your answer.  0.31. What is the difference between the highest and the lowest Net enrolment rate(%) of Lower middle income?
Give a very brief answer. 23.57. What is the difference between the highest and the lowest Net enrolment rate(%) of Central African Republic?
Your answer should be very brief. 21.4. What is the difference between the highest and the lowest Net enrolment rate(%) of Gambia, The?
Offer a very short reply. 46.63. What is the difference between the highest and the lowest Net enrolment rate(%) in Rwanda?
Make the answer very short. 44.44. 